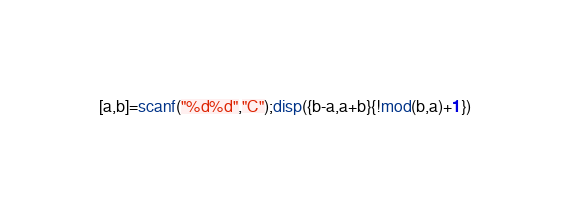Convert code to text. <code><loc_0><loc_0><loc_500><loc_500><_Octave_>[a,b]=scanf("%d%d","C");disp({b-a,a+b}{!mod(b,a)+1})</code> 